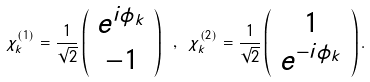<formula> <loc_0><loc_0><loc_500><loc_500>\chi ^ { ( 1 ) } _ { k } = \frac { 1 } { \sqrt { 2 } } \left ( \begin{array} { c } e ^ { i \phi _ { k } } \\ - 1 \end{array} \right ) \ , \ \chi ^ { ( 2 ) } _ { k } = \frac { 1 } { \sqrt { 2 } } \left ( \begin{array} { c } 1 \\ e ^ { - i \phi _ { k } } \end{array} \right ) .</formula> 